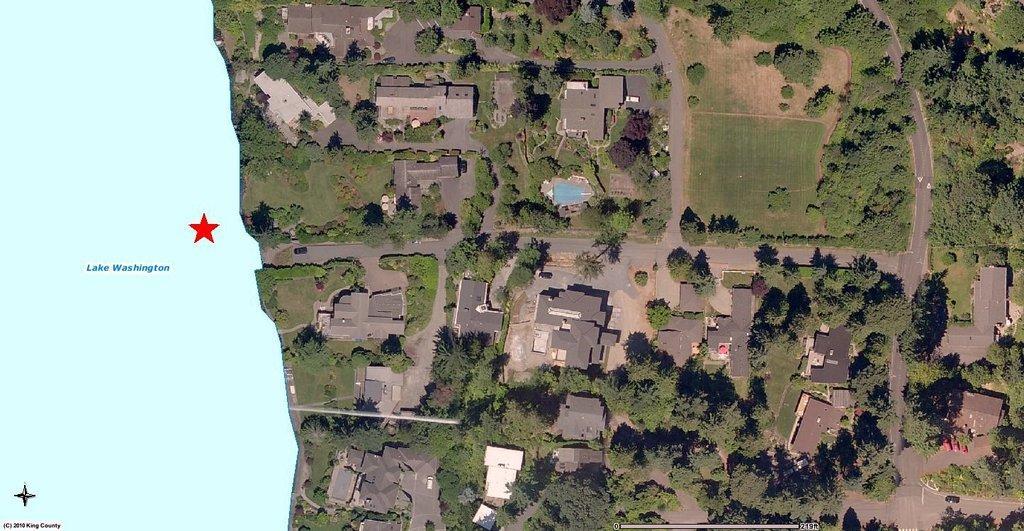Can you describe this image briefly? Here we can see an aerial view, in this picture we can see buildings, trees, grass and roads, on the left side we can see lake, at the left bottom there is some text. 